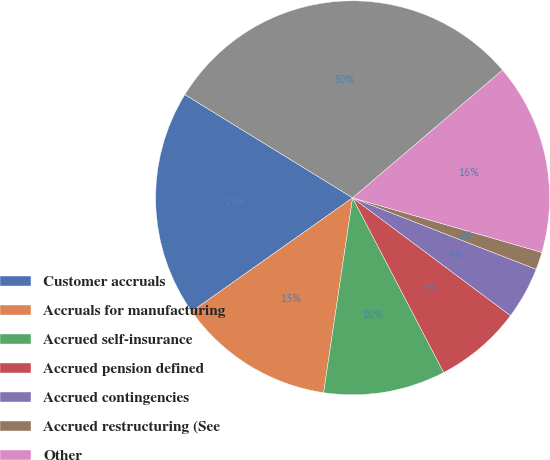<chart> <loc_0><loc_0><loc_500><loc_500><pie_chart><fcel>Customer accruals<fcel>Accruals for manufacturing<fcel>Accrued self-insurance<fcel>Accrued pension defined<fcel>Accrued contingencies<fcel>Accrued restructuring (See<fcel>Other<fcel>Other accrued liabilities<nl><fcel>18.57%<fcel>12.86%<fcel>10.0%<fcel>7.15%<fcel>4.29%<fcel>1.44%<fcel>15.71%<fcel>29.98%<nl></chart> 